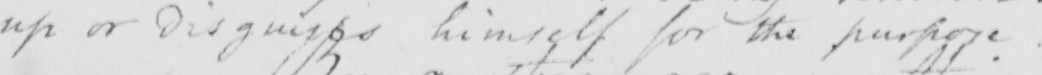Please provide the text content of this handwritten line. up or disguises himself for the purpose . 